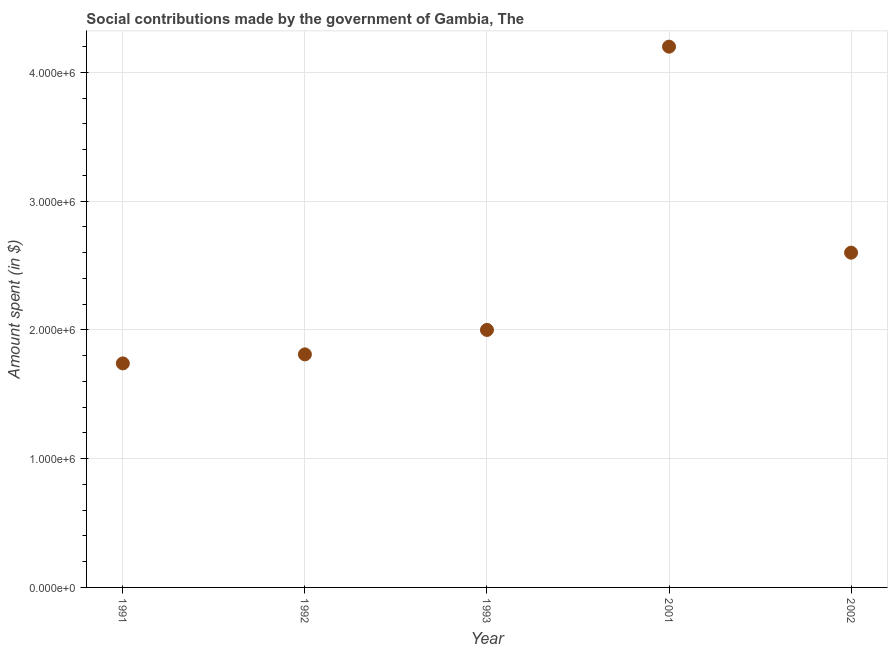What is the amount spent in making social contributions in 1992?
Ensure brevity in your answer.  1.81e+06. Across all years, what is the maximum amount spent in making social contributions?
Provide a short and direct response. 4.20e+06. Across all years, what is the minimum amount spent in making social contributions?
Your answer should be compact. 1.74e+06. In which year was the amount spent in making social contributions maximum?
Your answer should be very brief. 2001. In which year was the amount spent in making social contributions minimum?
Keep it short and to the point. 1991. What is the sum of the amount spent in making social contributions?
Make the answer very short. 1.24e+07. What is the difference between the amount spent in making social contributions in 1991 and 2001?
Your answer should be compact. -2.46e+06. What is the average amount spent in making social contributions per year?
Your response must be concise. 2.47e+06. What is the median amount spent in making social contributions?
Keep it short and to the point. 2.00e+06. In how many years, is the amount spent in making social contributions greater than 1800000 $?
Your answer should be compact. 4. What is the ratio of the amount spent in making social contributions in 1992 to that in 2002?
Your answer should be compact. 0.7. Is the amount spent in making social contributions in 1992 less than that in 1993?
Make the answer very short. Yes. Is the difference between the amount spent in making social contributions in 1991 and 2002 greater than the difference between any two years?
Offer a very short reply. No. What is the difference between the highest and the second highest amount spent in making social contributions?
Your answer should be very brief. 1.60e+06. Is the sum of the amount spent in making social contributions in 1991 and 2001 greater than the maximum amount spent in making social contributions across all years?
Provide a short and direct response. Yes. What is the difference between the highest and the lowest amount spent in making social contributions?
Keep it short and to the point. 2.46e+06. In how many years, is the amount spent in making social contributions greater than the average amount spent in making social contributions taken over all years?
Provide a succinct answer. 2. How many dotlines are there?
Provide a short and direct response. 1. What is the difference between two consecutive major ticks on the Y-axis?
Your answer should be compact. 1.00e+06. Does the graph contain grids?
Your answer should be compact. Yes. What is the title of the graph?
Provide a succinct answer. Social contributions made by the government of Gambia, The. What is the label or title of the X-axis?
Offer a terse response. Year. What is the label or title of the Y-axis?
Your response must be concise. Amount spent (in $). What is the Amount spent (in $) in 1991?
Offer a very short reply. 1.74e+06. What is the Amount spent (in $) in 1992?
Ensure brevity in your answer.  1.81e+06. What is the Amount spent (in $) in 2001?
Keep it short and to the point. 4.20e+06. What is the Amount spent (in $) in 2002?
Keep it short and to the point. 2.60e+06. What is the difference between the Amount spent (in $) in 1991 and 1992?
Your answer should be very brief. -7.00e+04. What is the difference between the Amount spent (in $) in 1991 and 2001?
Give a very brief answer. -2.46e+06. What is the difference between the Amount spent (in $) in 1991 and 2002?
Your answer should be very brief. -8.60e+05. What is the difference between the Amount spent (in $) in 1992 and 2001?
Provide a succinct answer. -2.39e+06. What is the difference between the Amount spent (in $) in 1992 and 2002?
Ensure brevity in your answer.  -7.90e+05. What is the difference between the Amount spent (in $) in 1993 and 2001?
Your response must be concise. -2.20e+06. What is the difference between the Amount spent (in $) in 1993 and 2002?
Offer a terse response. -6.00e+05. What is the difference between the Amount spent (in $) in 2001 and 2002?
Offer a very short reply. 1.60e+06. What is the ratio of the Amount spent (in $) in 1991 to that in 1993?
Your answer should be compact. 0.87. What is the ratio of the Amount spent (in $) in 1991 to that in 2001?
Offer a terse response. 0.41. What is the ratio of the Amount spent (in $) in 1991 to that in 2002?
Your answer should be compact. 0.67. What is the ratio of the Amount spent (in $) in 1992 to that in 1993?
Offer a very short reply. 0.91. What is the ratio of the Amount spent (in $) in 1992 to that in 2001?
Your response must be concise. 0.43. What is the ratio of the Amount spent (in $) in 1992 to that in 2002?
Provide a succinct answer. 0.7. What is the ratio of the Amount spent (in $) in 1993 to that in 2001?
Make the answer very short. 0.48. What is the ratio of the Amount spent (in $) in 1993 to that in 2002?
Make the answer very short. 0.77. What is the ratio of the Amount spent (in $) in 2001 to that in 2002?
Provide a short and direct response. 1.61. 